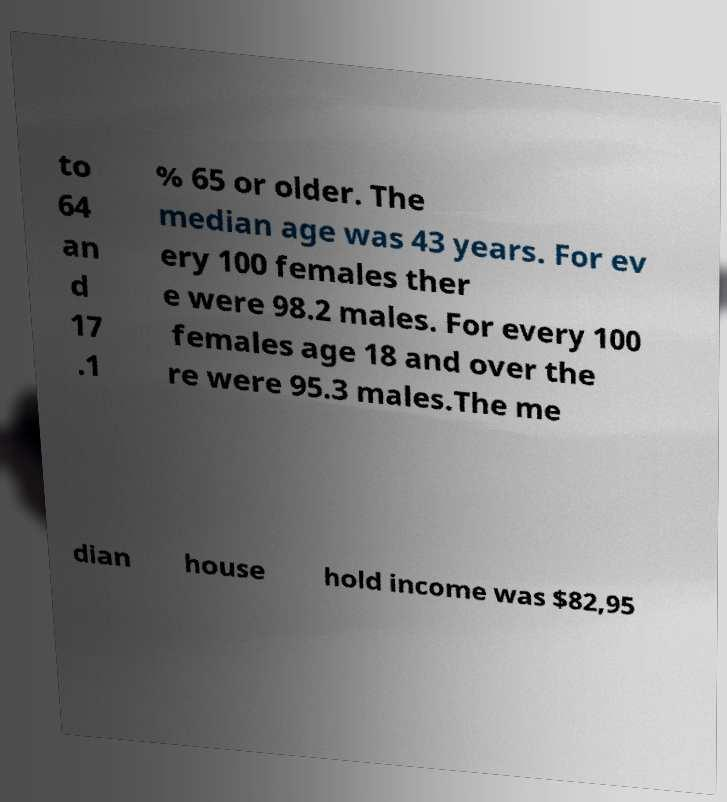Can you read and provide the text displayed in the image?This photo seems to have some interesting text. Can you extract and type it out for me? to 64 an d 17 .1 % 65 or older. The median age was 43 years. For ev ery 100 females ther e were 98.2 males. For every 100 females age 18 and over the re were 95.3 males.The me dian house hold income was $82,95 